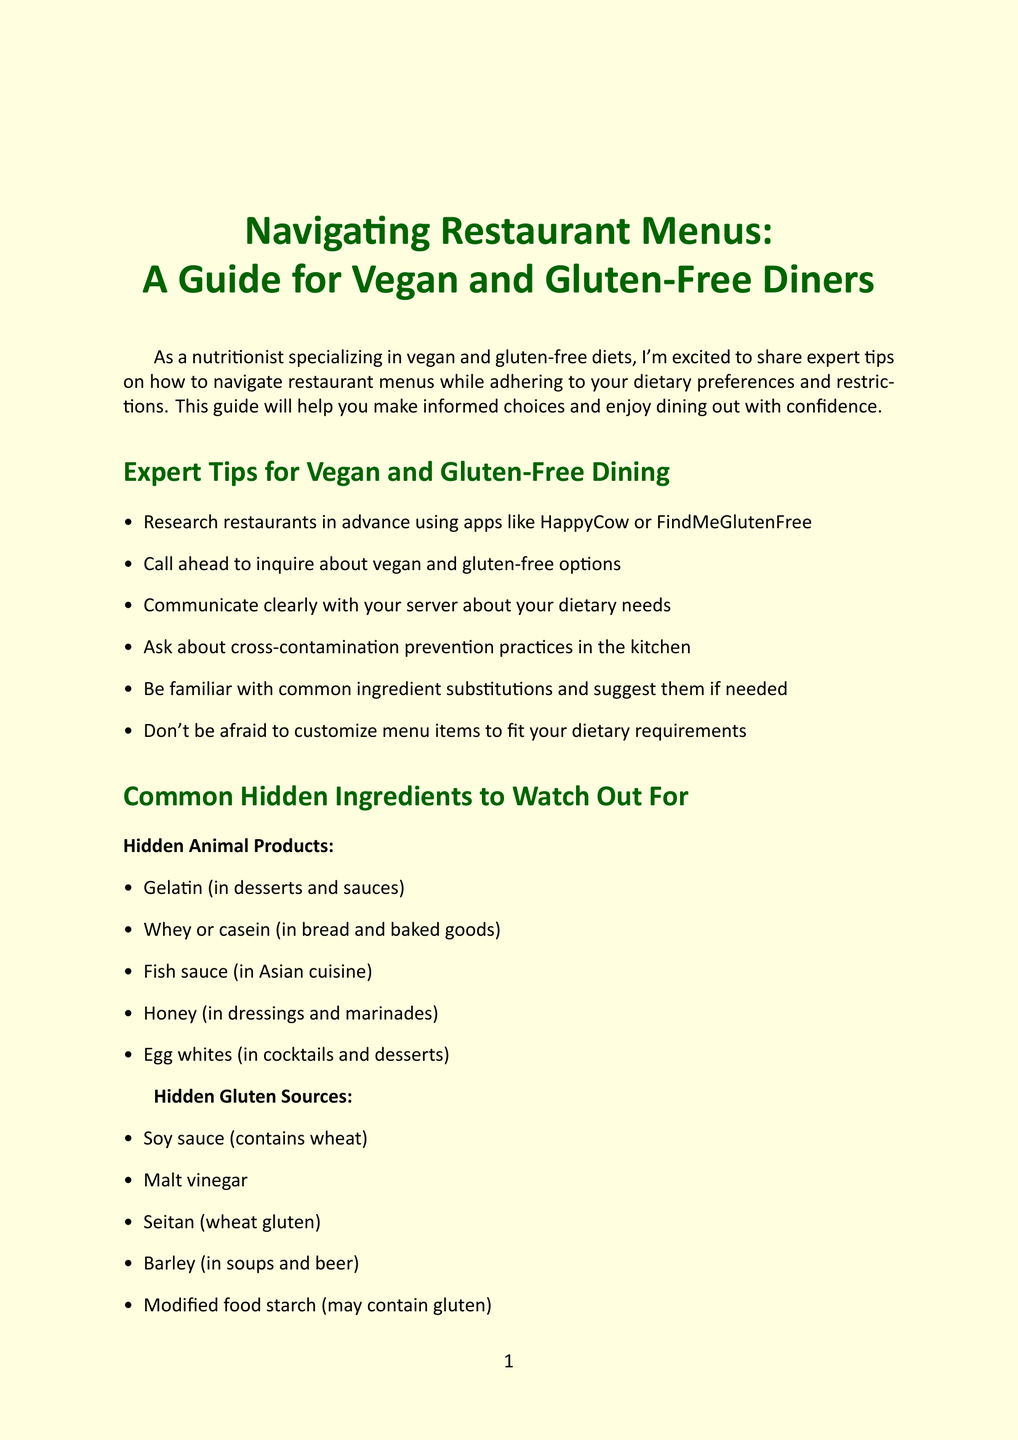What is the title of the newsletter? The title is provided at the beginning of the document and is specifically mentioned in the introduction.
Answer: Navigating Restaurant Menus: A Guide for Vegan and Gluten-Free Diners How many sections are in the newsletter? The newsletter contains multiple sections, each identified by their titles, and is included in the structure of the document.
Answer: 6 What should you research in advance? This tip emphasizes the importance of preparation before dining out and is listed under expert tips.
Answer: Restaurants What is a vegan and gluten-free friendly cuisine? The newsletter lists several cuisines that cater to vegan and gluten-free diets.
Answer: Indian cuisine What is a common hidden animal product? This information is found in the section that discusses hidden ingredients to watch out for when dining out.
Answer: Gelatin Which restaurant chain has a dedicated gluten-free menu with vegan options? This is mentioned in the section that highlights popular restaurant chains that accommodate vegan and gluten-free diets.
Answer: P.F. Chang's What can be used instead of soy sauce? This suggestion relates to ingredient substitutions advised in the newsletter to cater to dietary needs.
Answer: Tamari What ingredient can replace eggs in baking? This substitution is specifically mentioned in the list of ingredient suggestions for vegan and gluten-free diets.
Answer: Flax or chia seeds How does the author see their role in the dining experience? This reflects the author's view as stated in the concluding section of the newsletter.
Answer: Empowering individuals 